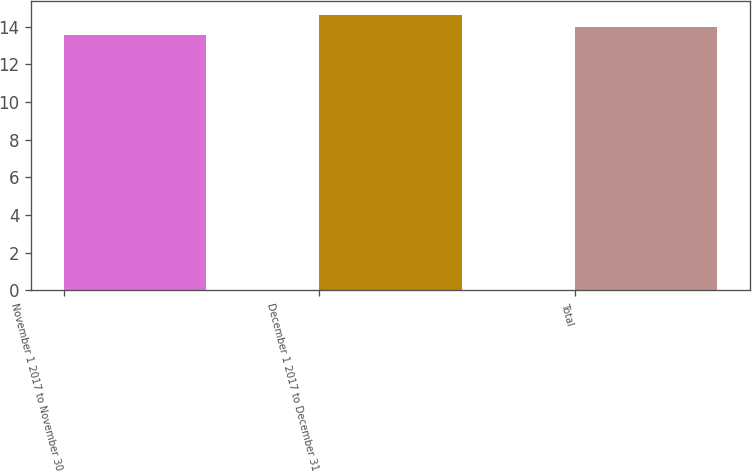Convert chart. <chart><loc_0><loc_0><loc_500><loc_500><bar_chart><fcel>November 1 2017 to November 30<fcel>December 1 2017 to December 31<fcel>Total<nl><fcel>13.58<fcel>14.62<fcel>14<nl></chart> 